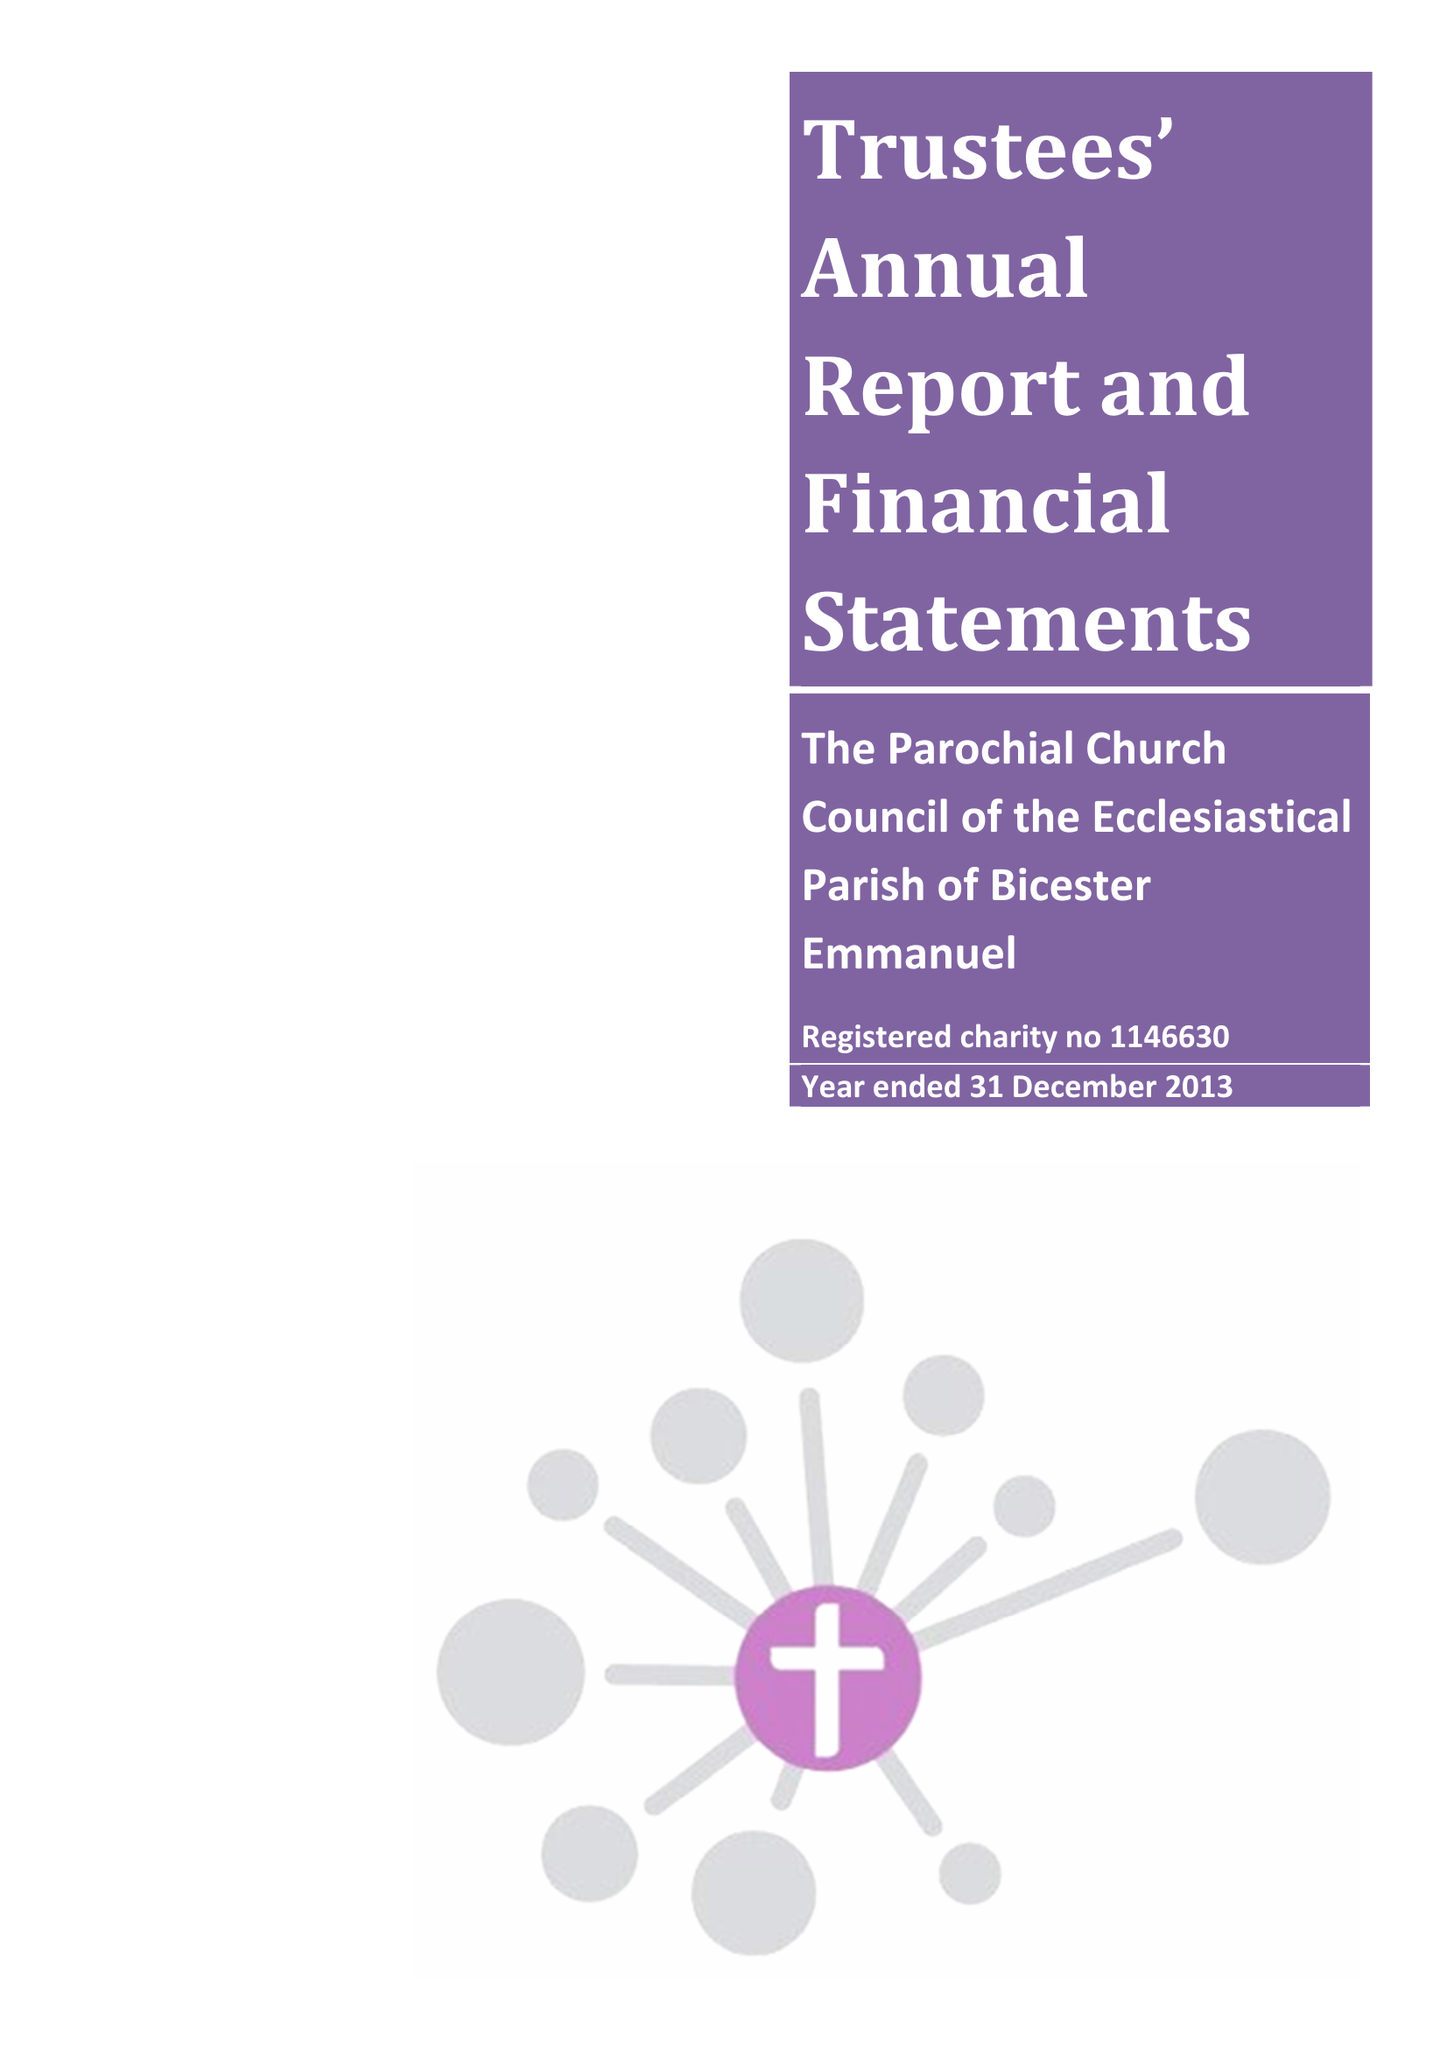What is the value for the charity_number?
Answer the question using a single word or phrase. 1146630 